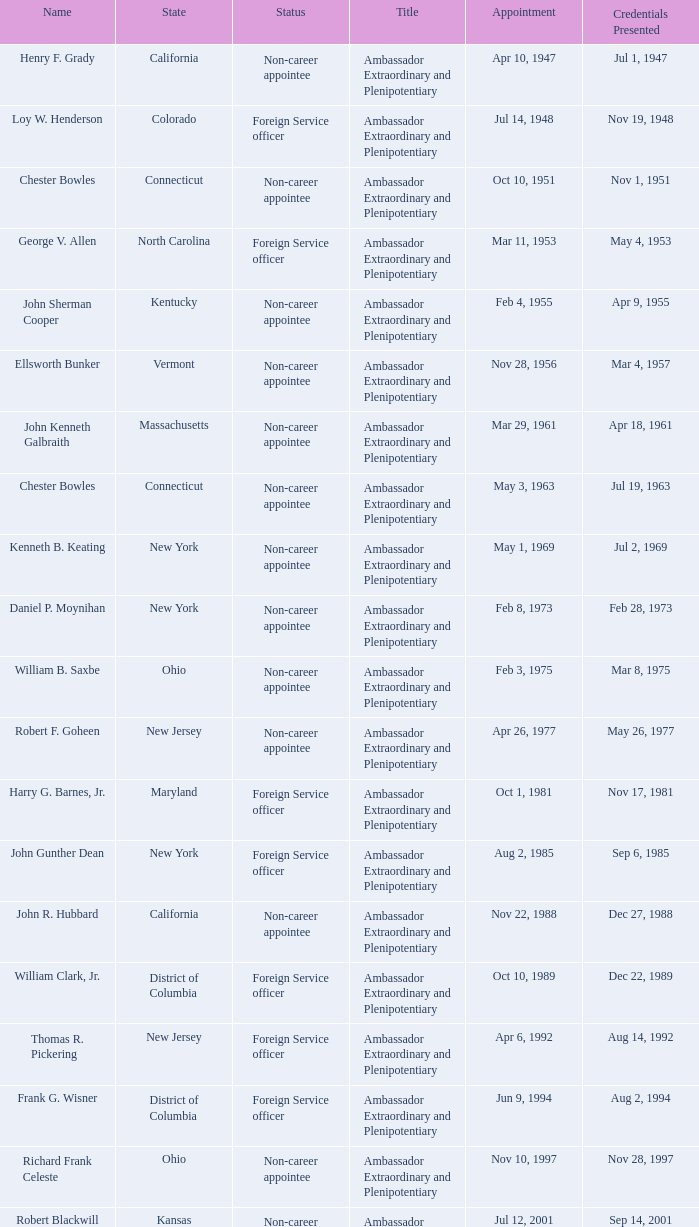Help me parse the entirety of this table. {'header': ['Name', 'State', 'Status', 'Title', 'Appointment', 'Credentials Presented'], 'rows': [['Henry F. Grady', 'California', 'Non-career appointee', 'Ambassador Extraordinary and Plenipotentiary', 'Apr 10, 1947', 'Jul 1, 1947'], ['Loy W. Henderson', 'Colorado', 'Foreign Service officer', 'Ambassador Extraordinary and Plenipotentiary', 'Jul 14, 1948', 'Nov 19, 1948'], ['Chester Bowles', 'Connecticut', 'Non-career appointee', 'Ambassador Extraordinary and Plenipotentiary', 'Oct 10, 1951', 'Nov 1, 1951'], ['George V. Allen', 'North Carolina', 'Foreign Service officer', 'Ambassador Extraordinary and Plenipotentiary', 'Mar 11, 1953', 'May 4, 1953'], ['John Sherman Cooper', 'Kentucky', 'Non-career appointee', 'Ambassador Extraordinary and Plenipotentiary', 'Feb 4, 1955', 'Apr 9, 1955'], ['Ellsworth Bunker', 'Vermont', 'Non-career appointee', 'Ambassador Extraordinary and Plenipotentiary', 'Nov 28, 1956', 'Mar 4, 1957'], ['John Kenneth Galbraith', 'Massachusetts', 'Non-career appointee', 'Ambassador Extraordinary and Plenipotentiary', 'Mar 29, 1961', 'Apr 18, 1961'], ['Chester Bowles', 'Connecticut', 'Non-career appointee', 'Ambassador Extraordinary and Plenipotentiary', 'May 3, 1963', 'Jul 19, 1963'], ['Kenneth B. Keating', 'New York', 'Non-career appointee', 'Ambassador Extraordinary and Plenipotentiary', 'May 1, 1969', 'Jul 2, 1969'], ['Daniel P. Moynihan', 'New York', 'Non-career appointee', 'Ambassador Extraordinary and Plenipotentiary', 'Feb 8, 1973', 'Feb 28, 1973'], ['William B. Saxbe', 'Ohio', 'Non-career appointee', 'Ambassador Extraordinary and Plenipotentiary', 'Feb 3, 1975', 'Mar 8, 1975'], ['Robert F. Goheen', 'New Jersey', 'Non-career appointee', 'Ambassador Extraordinary and Plenipotentiary', 'Apr 26, 1977', 'May 26, 1977'], ['Harry G. Barnes, Jr.', 'Maryland', 'Foreign Service officer', 'Ambassador Extraordinary and Plenipotentiary', 'Oct 1, 1981', 'Nov 17, 1981'], ['John Gunther Dean', 'New York', 'Foreign Service officer', 'Ambassador Extraordinary and Plenipotentiary', 'Aug 2, 1985', 'Sep 6, 1985'], ['John R. Hubbard', 'California', 'Non-career appointee', 'Ambassador Extraordinary and Plenipotentiary', 'Nov 22, 1988', 'Dec 27, 1988'], ['William Clark, Jr.', 'District of Columbia', 'Foreign Service officer', 'Ambassador Extraordinary and Plenipotentiary', 'Oct 10, 1989', 'Dec 22, 1989'], ['Thomas R. Pickering', 'New Jersey', 'Foreign Service officer', 'Ambassador Extraordinary and Plenipotentiary', 'Apr 6, 1992', 'Aug 14, 1992'], ['Frank G. Wisner', 'District of Columbia', 'Foreign Service officer', 'Ambassador Extraordinary and Plenipotentiary', 'Jun 9, 1994', 'Aug 2, 1994'], ['Richard Frank Celeste', 'Ohio', 'Non-career appointee', 'Ambassador Extraordinary and Plenipotentiary', 'Nov 10, 1997', 'Nov 28, 1997'], ['Robert Blackwill', 'Kansas', 'Non-career appointee', 'Ambassador Extraordinary and Plenipotentiary', 'Jul 12, 2001', 'Sep 14, 2001'], ['David Campbell Mulford', 'Illinois', 'Non-career officer', 'Ambassador Extraordinary and Plenipotentiary', 'Dec 12, 2003', 'Feb 23, 2004'], ['Timothy J. Roemer', 'Indiana', 'Non-career appointee', 'Ambassador Extraordinary and Plenipotentiary', 'Jul 23, 2009', 'Aug 11, 2009'], ['Albert Peter Burleigh', 'California', 'Foreign Service officer', "Charge d'affaires", 'June 2011', 'Left post 2012'], ['Nancy Jo Powell', 'Iowa', 'Foreign Service officer', 'Ambassador Extraordinary and Plenipotentiary', 'February 7, 2012', 'April 19, 2012']]} What is the title for david campbell mulford? Ambassador Extraordinary and Plenipotentiary. 